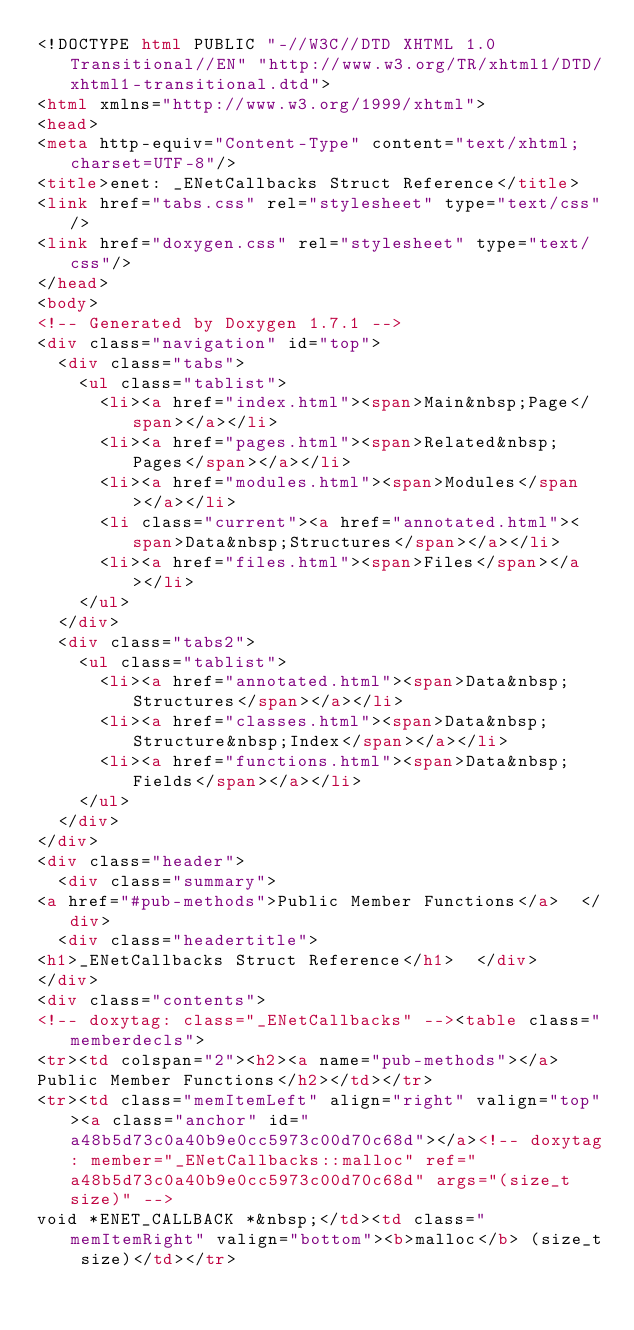<code> <loc_0><loc_0><loc_500><loc_500><_HTML_><!DOCTYPE html PUBLIC "-//W3C//DTD XHTML 1.0 Transitional//EN" "http://www.w3.org/TR/xhtml1/DTD/xhtml1-transitional.dtd">
<html xmlns="http://www.w3.org/1999/xhtml">
<head>
<meta http-equiv="Content-Type" content="text/xhtml;charset=UTF-8"/>
<title>enet: _ENetCallbacks Struct Reference</title>
<link href="tabs.css" rel="stylesheet" type="text/css"/>
<link href="doxygen.css" rel="stylesheet" type="text/css"/>
</head>
<body>
<!-- Generated by Doxygen 1.7.1 -->
<div class="navigation" id="top">
  <div class="tabs">
    <ul class="tablist">
      <li><a href="index.html"><span>Main&nbsp;Page</span></a></li>
      <li><a href="pages.html"><span>Related&nbsp;Pages</span></a></li>
      <li><a href="modules.html"><span>Modules</span></a></li>
      <li class="current"><a href="annotated.html"><span>Data&nbsp;Structures</span></a></li>
      <li><a href="files.html"><span>Files</span></a></li>
    </ul>
  </div>
  <div class="tabs2">
    <ul class="tablist">
      <li><a href="annotated.html"><span>Data&nbsp;Structures</span></a></li>
      <li><a href="classes.html"><span>Data&nbsp;Structure&nbsp;Index</span></a></li>
      <li><a href="functions.html"><span>Data&nbsp;Fields</span></a></li>
    </ul>
  </div>
</div>
<div class="header">
  <div class="summary">
<a href="#pub-methods">Public Member Functions</a>  </div>
  <div class="headertitle">
<h1>_ENetCallbacks Struct Reference</h1>  </div>
</div>
<div class="contents">
<!-- doxytag: class="_ENetCallbacks" --><table class="memberdecls">
<tr><td colspan="2"><h2><a name="pub-methods"></a>
Public Member Functions</h2></td></tr>
<tr><td class="memItemLeft" align="right" valign="top"><a class="anchor" id="a48b5d73c0a40b9e0cc5973c00d70c68d"></a><!-- doxytag: member="_ENetCallbacks::malloc" ref="a48b5d73c0a40b9e0cc5973c00d70c68d" args="(size_t size)" -->
void *ENET_CALLBACK *&nbsp;</td><td class="memItemRight" valign="bottom"><b>malloc</b> (size_t size)</td></tr></code> 